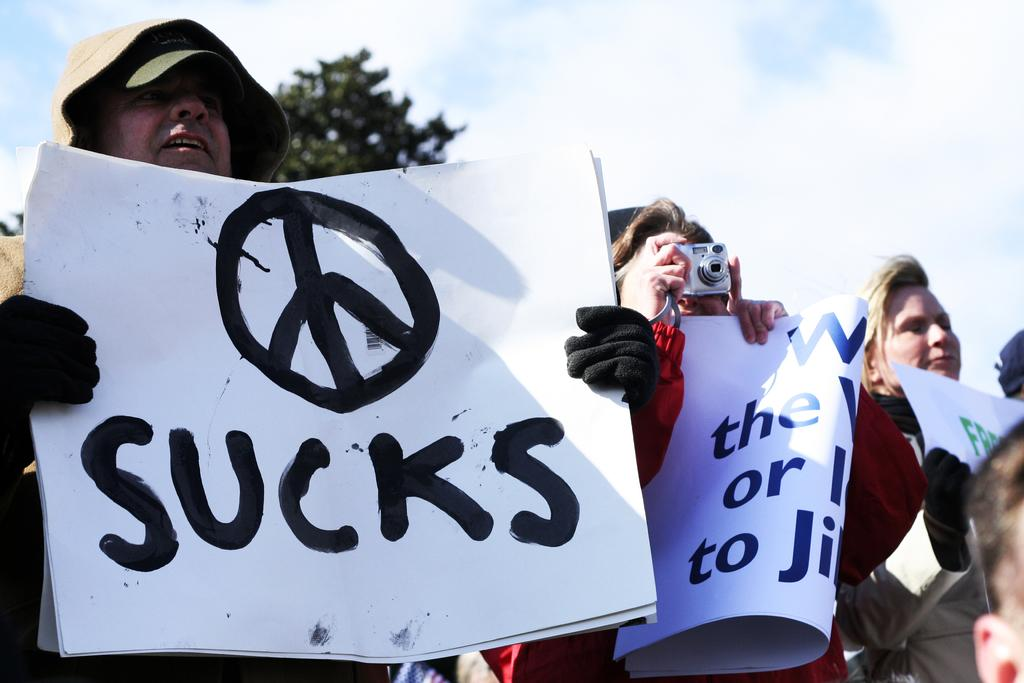How many people are in the image? There is a group of people in the image, but the exact number is not specified. What are some people doing in the image? Some people are holding placards in the image. What object is used to capture the scene in the image? There is a camera in the image. What type of natural element can be seen in the image? There is a tree in the image. What color is the heart-shaped light in the image? There is no heart-shaped light present in the image. Can you describe the ant crawling on the tree in the image? There is no ant present in the image; it only features a group of people, placards, a camera, and a tree. 